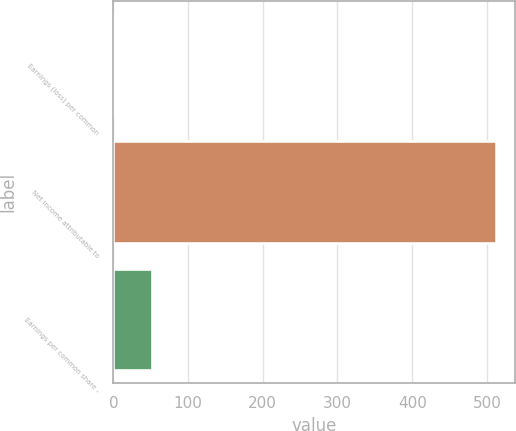Convert chart to OTSL. <chart><loc_0><loc_0><loc_500><loc_500><bar_chart><fcel>Earnings (loss) per common<fcel>Net income attributable to<fcel>Earnings per common share -<nl><fcel>1.18<fcel>512<fcel>52.26<nl></chart> 